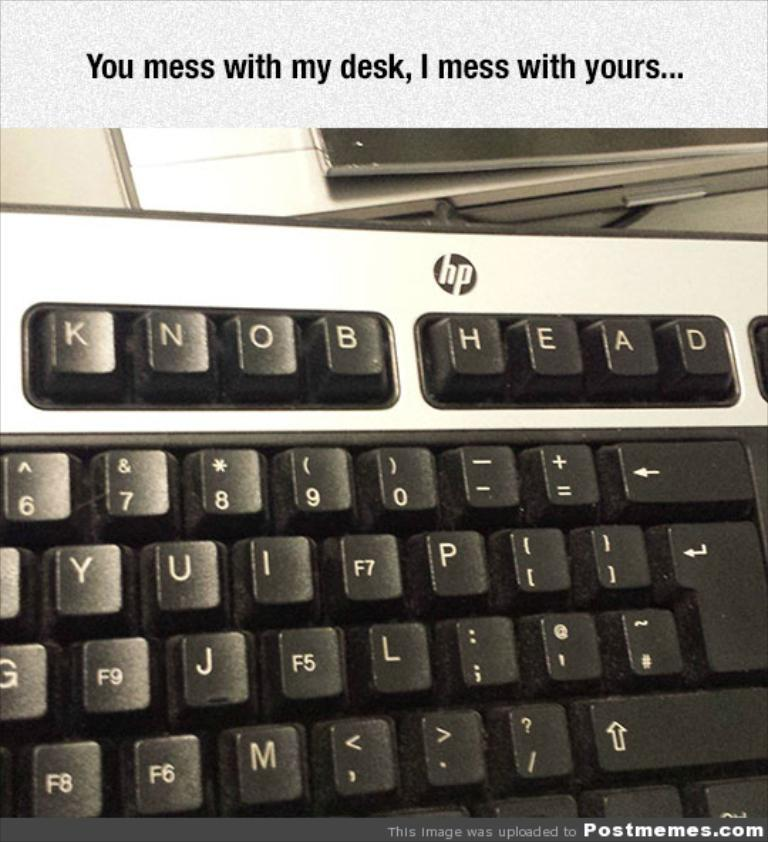<image>
Present a compact description of the photo's key features. HP Keyboard that says Knob Head, and has the text on top saying: You mess with my desk, I mess with yours... 